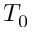Convert formula to latex. <formula><loc_0><loc_0><loc_500><loc_500>T _ { 0 }</formula> 